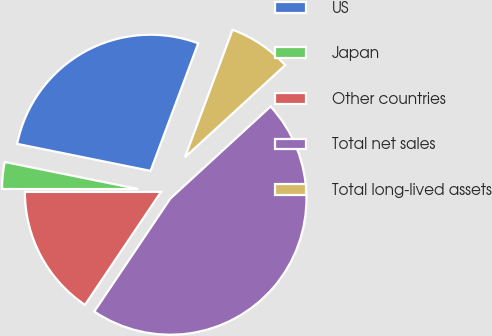<chart> <loc_0><loc_0><loc_500><loc_500><pie_chart><fcel>US<fcel>Japan<fcel>Other countries<fcel>Total net sales<fcel>Total long-lived assets<nl><fcel>27.51%<fcel>3.18%<fcel>15.57%<fcel>46.26%<fcel>7.49%<nl></chart> 